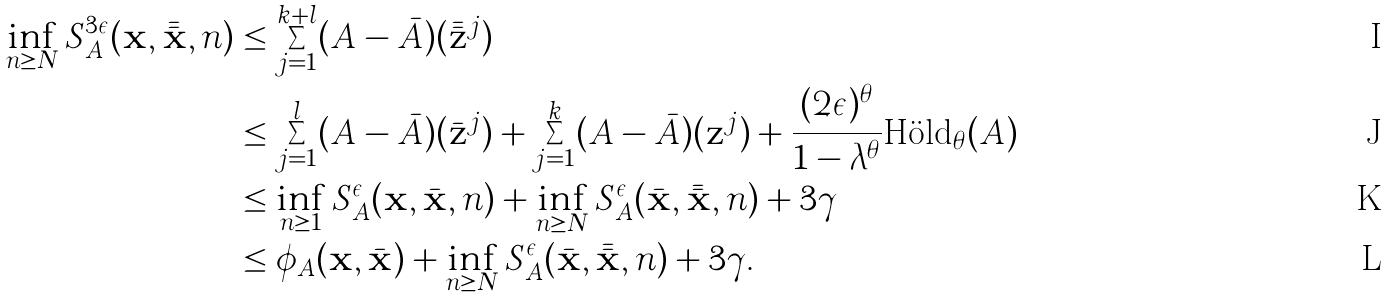Convert formula to latex. <formula><loc_0><loc_0><loc_500><loc_500>\inf _ { n \geq N } S _ { A } ^ { 3 \epsilon } ( \mathbf x , \bar { \bar { \mathbf x } } , n ) & \leq \sum _ { j = 1 } ^ { k + l } ( A - \bar { A } ) ( \bar { \bar { \mathbf z } } ^ { j } ) \\ & \leq \sum _ { j = 1 } ^ { l } ( A - \bar { A } ) ( \bar { \mathbf z } ^ { j } ) + \sum _ { j = 1 } ^ { k } ( A - \bar { A } ) ( \mathbf z ^ { j } ) + \frac { ( 2 \epsilon ) ^ { \theta } } { 1 - \lambda ^ { \theta } } \text {H\"old} _ { \theta } ( A ) \\ & \leq \inf _ { n \geq 1 } S _ { A } ^ { \epsilon } ( \mathbf x , \bar { \mathbf x } , n ) + \inf _ { n \geq N } S _ { A } ^ { \epsilon } ( \bar { \mathbf x } , \bar { \bar { \mathbf x } } , n ) + 3 \gamma \\ & \leq \phi _ { A } ( \mathbf x , \bar { \mathbf x } ) + \inf _ { n \geq N } S _ { A } ^ { \epsilon } ( \bar { \mathbf x } , \bar { \bar { \mathbf x } } , n ) + 3 \gamma .</formula> 